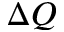<formula> <loc_0><loc_0><loc_500><loc_500>\Delta Q</formula> 